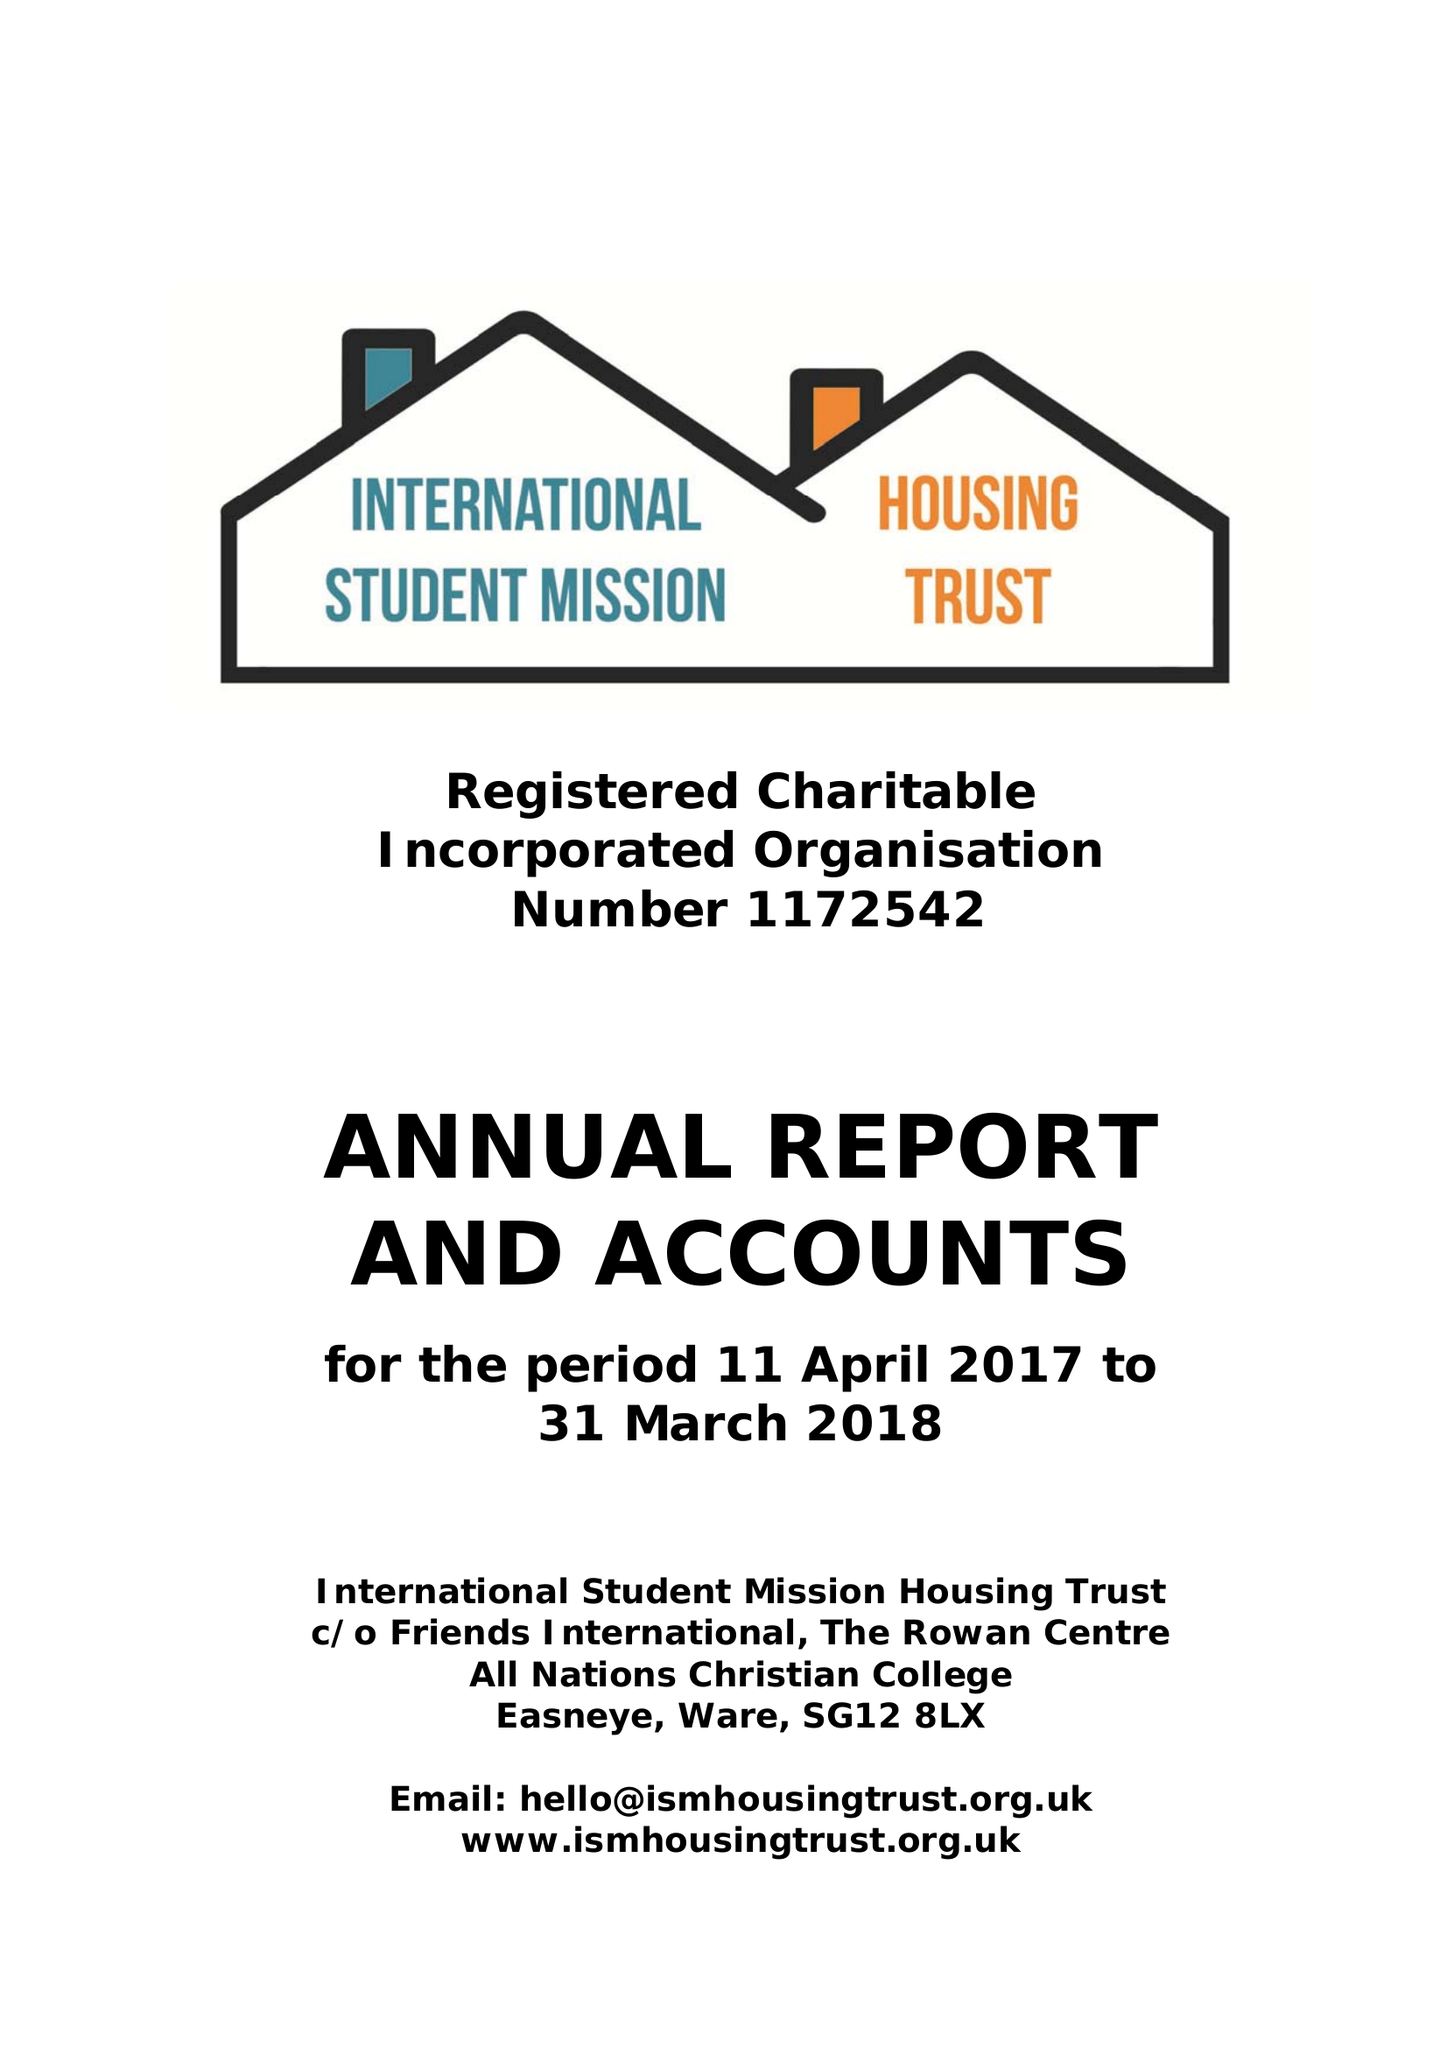What is the value for the spending_annually_in_british_pounds?
Answer the question using a single word or phrase. 12280.00 